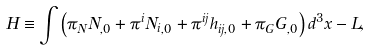Convert formula to latex. <formula><loc_0><loc_0><loc_500><loc_500>H \equiv \int \left ( \pi _ { N } N _ { , 0 } + \pi ^ { i } { N _ { i } } _ { , 0 } + \pi ^ { i j } h _ { i j , 0 } + \pi _ { G } G _ { , 0 } \right ) d ^ { 3 } x - L ,</formula> 